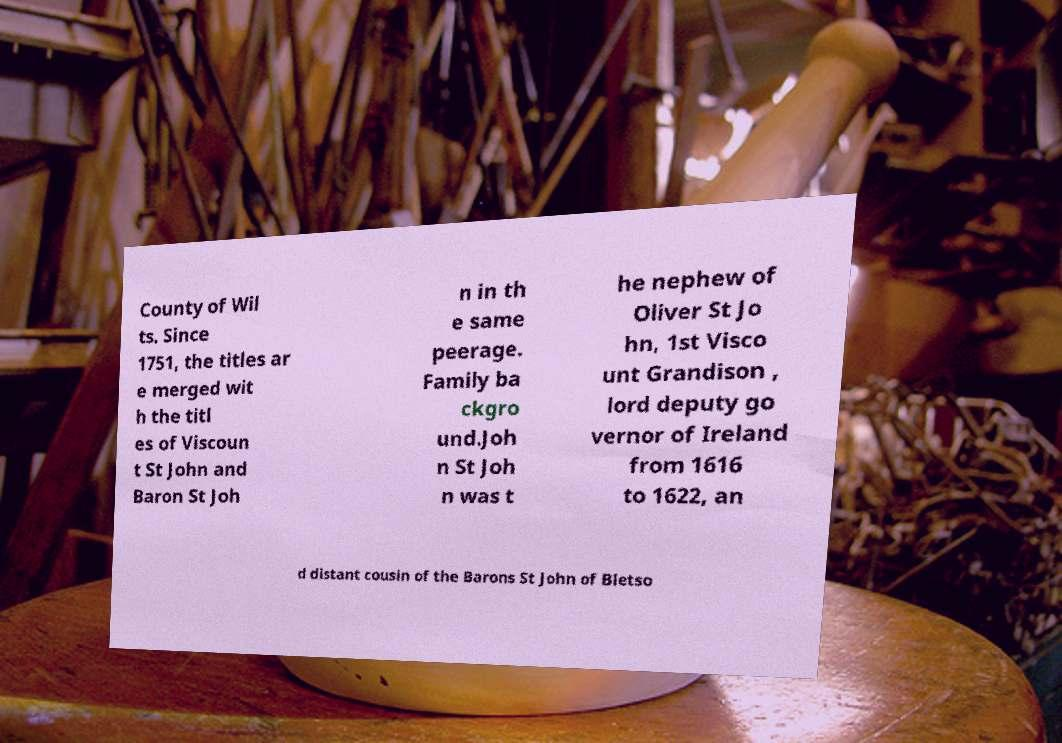Could you extract and type out the text from this image? County of Wil ts. Since 1751, the titles ar e merged wit h the titl es of Viscoun t St John and Baron St Joh n in th e same peerage. Family ba ckgro und.Joh n St Joh n was t he nephew of Oliver St Jo hn, 1st Visco unt Grandison , lord deputy go vernor of Ireland from 1616 to 1622, an d distant cousin of the Barons St John of Bletso 